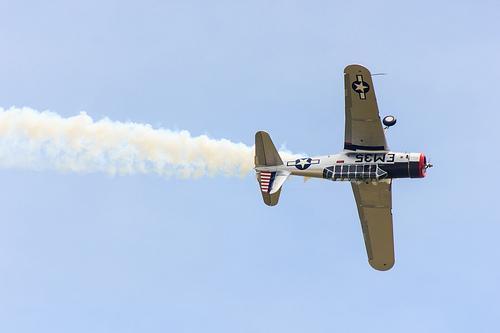How many stars can you see on the plane?
Give a very brief answer. 2. 